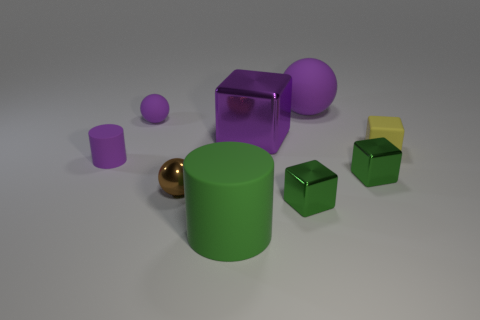How many cylinders are the same color as the large block?
Keep it short and to the point. 1. What number of other objects are the same color as the small matte cube?
Offer a terse response. 0. The brown metallic ball has what size?
Give a very brief answer. Small. Are any large purple objects visible?
Offer a very short reply. Yes. Are there more green cylinders that are left of the large matte cylinder than small shiny blocks right of the tiny shiny ball?
Your response must be concise. No. What material is the small object that is behind the tiny purple rubber cylinder and to the left of the yellow object?
Your answer should be very brief. Rubber. Is the shape of the green rubber thing the same as the tiny yellow rubber thing?
Ensure brevity in your answer.  No. Are there any other things that are the same size as the brown thing?
Give a very brief answer. Yes. There is a purple cylinder; how many big cubes are in front of it?
Your answer should be compact. 0. Is the size of the green cube that is in front of the brown ball the same as the small brown shiny ball?
Your response must be concise. Yes. 